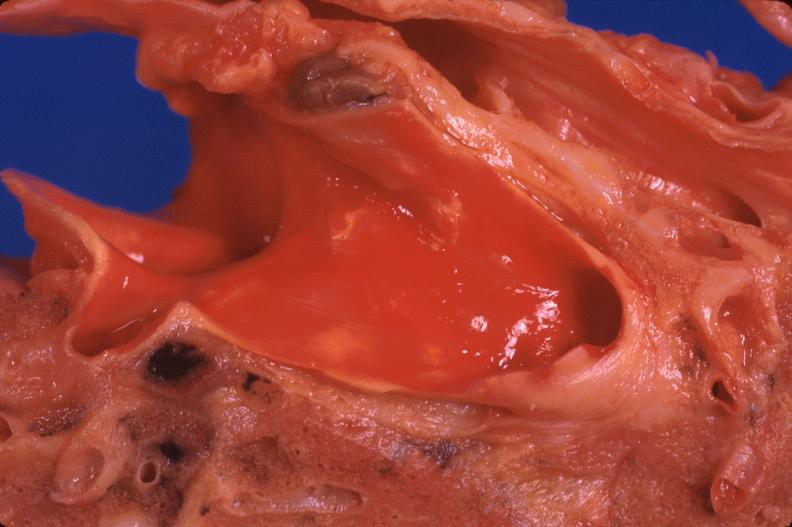what is present?
Answer the question using a single word or phrase. Respiratory 